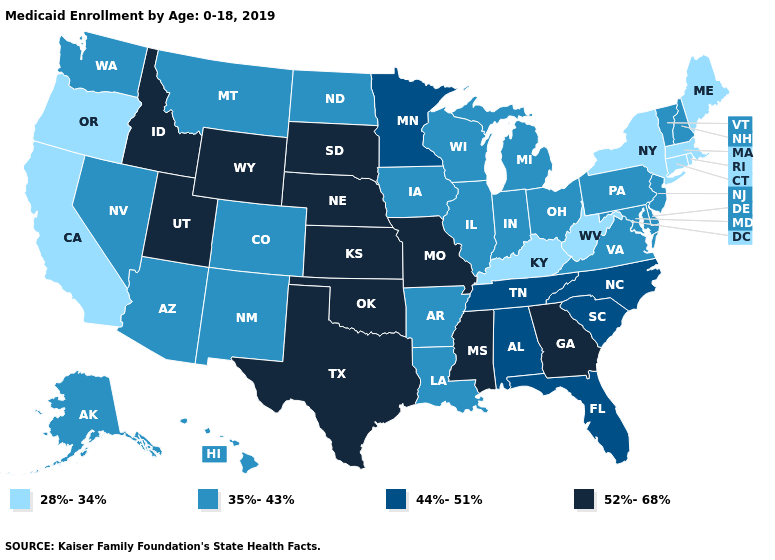Is the legend a continuous bar?
Be succinct. No. How many symbols are there in the legend?
Short answer required. 4. Which states have the lowest value in the Northeast?
Concise answer only. Connecticut, Maine, Massachusetts, New York, Rhode Island. Does Indiana have a higher value than Nevada?
Quick response, please. No. Does Minnesota have a lower value than Texas?
Give a very brief answer. Yes. Among the states that border Wyoming , which have the lowest value?
Short answer required. Colorado, Montana. Name the states that have a value in the range 35%-43%?
Answer briefly. Alaska, Arizona, Arkansas, Colorado, Delaware, Hawaii, Illinois, Indiana, Iowa, Louisiana, Maryland, Michigan, Montana, Nevada, New Hampshire, New Jersey, New Mexico, North Dakota, Ohio, Pennsylvania, Vermont, Virginia, Washington, Wisconsin. Does the first symbol in the legend represent the smallest category?
Keep it brief. Yes. Is the legend a continuous bar?
Be succinct. No. What is the highest value in states that border North Dakota?
Short answer required. 52%-68%. Name the states that have a value in the range 44%-51%?
Concise answer only. Alabama, Florida, Minnesota, North Carolina, South Carolina, Tennessee. Name the states that have a value in the range 44%-51%?
Quick response, please. Alabama, Florida, Minnesota, North Carolina, South Carolina, Tennessee. Name the states that have a value in the range 35%-43%?
Answer briefly. Alaska, Arizona, Arkansas, Colorado, Delaware, Hawaii, Illinois, Indiana, Iowa, Louisiana, Maryland, Michigan, Montana, Nevada, New Hampshire, New Jersey, New Mexico, North Dakota, Ohio, Pennsylvania, Vermont, Virginia, Washington, Wisconsin. Among the states that border Mississippi , does Arkansas have the highest value?
Keep it brief. No. Among the states that border South Dakota , which have the lowest value?
Give a very brief answer. Iowa, Montana, North Dakota. 